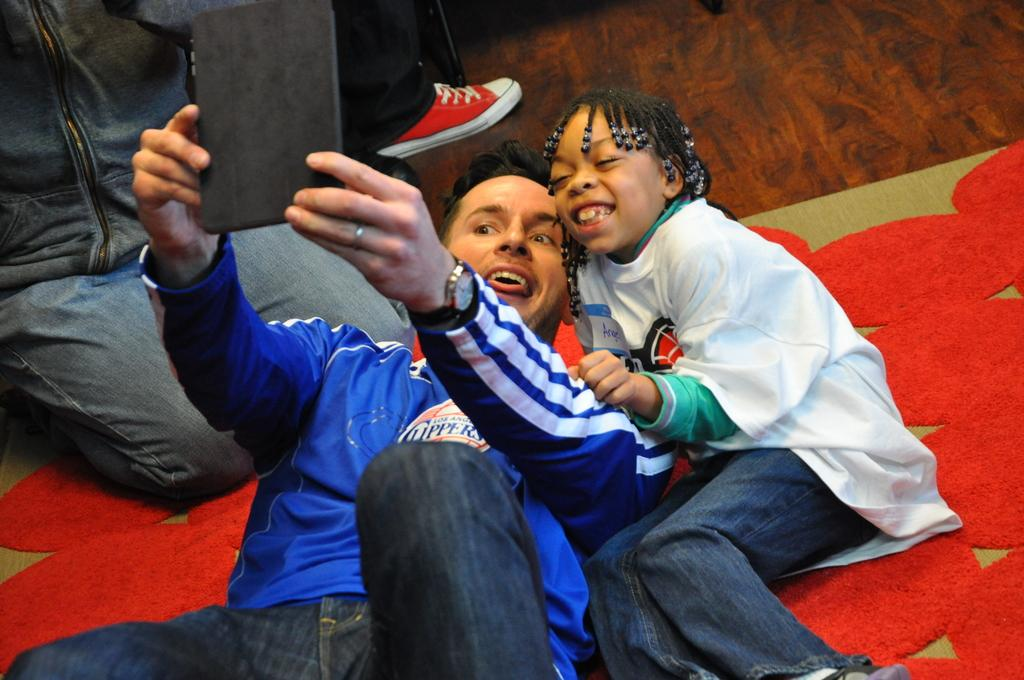How many people are in the image? There are people in the image, but the exact number is not specified. What is the expression of the girl in the image? A girl is smiling in the image. What is the man holding in the image? The man is holding a gadget in the image. What is on the floor in the image? There is a mat on the floor in the image. What type of trains can be heard in the background of the image? There is no mention of trains or any sounds in the image, so it is not possible to determine if any trains can be heard. 